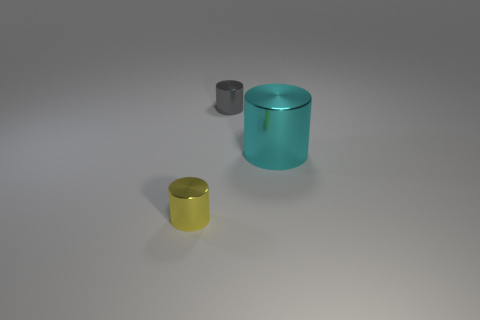Subtract all tiny metallic cylinders. How many cylinders are left? 1 Add 2 small gray spheres. How many objects exist? 5 Subtract 2 cylinders. How many cylinders are left? 1 Subtract all gray cylinders. How many cylinders are left? 2 Subtract all big yellow shiny spheres. Subtract all cylinders. How many objects are left? 0 Add 1 metallic things. How many metallic things are left? 4 Add 1 gray metal cylinders. How many gray metal cylinders exist? 2 Subtract 1 gray cylinders. How many objects are left? 2 Subtract all brown cylinders. Subtract all cyan balls. How many cylinders are left? 3 Subtract all red cubes. How many yellow cylinders are left? 1 